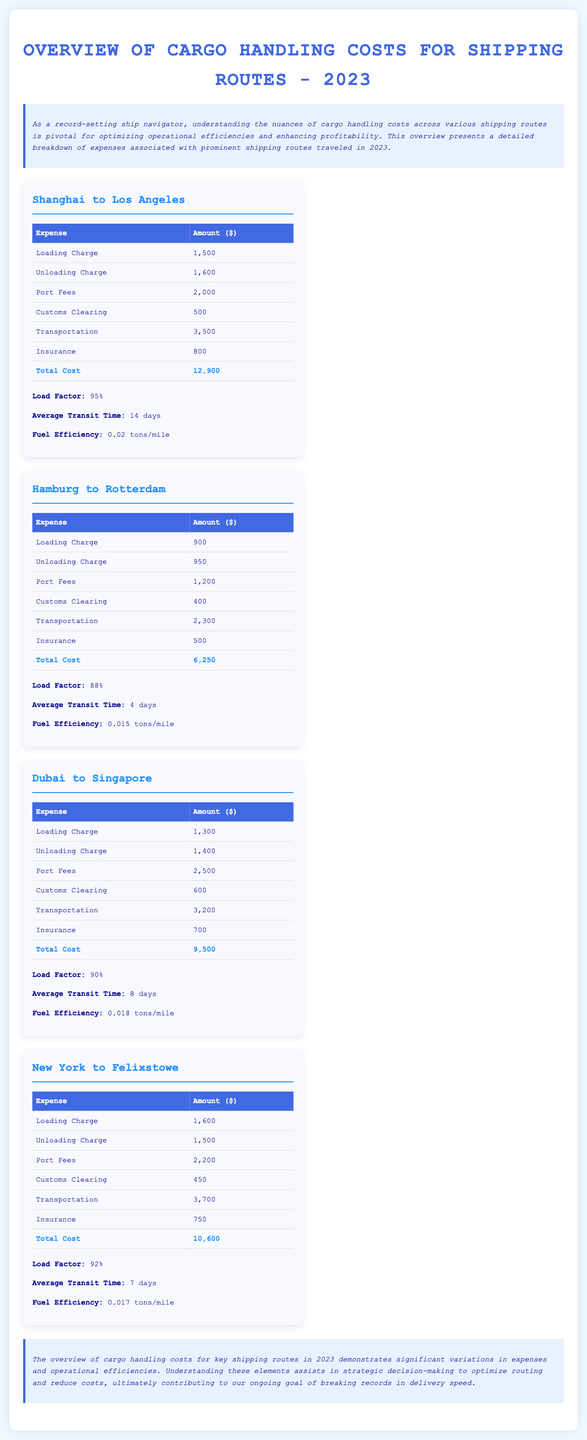what is the total cost for the Shanghai to Los Angeles route? The total cost for the Shanghai to Los Angeles route is specifically mentioned in the expenses table under total cost.
Answer: 12,900 what is the average transit time for the Hamburg to Rotterdam route? The average transit time is provided in the operational efficiencies section for that specific route.
Answer: 4 days which route has the highest loading charge? By comparing the loading charges for each route provided, we can determine which one is the highest.
Answer: New York to Felixstowe what is the load factor for the Dubai to Singapore route? The load factor is indicated in the efficiency details for the Dubai to Singapore route.
Answer: 90% how much is the insurance cost for the Hamburg to Rotterdam route? The insurance cost can be found in the expenses table for the Hamburg to Rotterdam route.
Answer: 500 which route has the lowest total cost? By analyzing the total costs listed for each route, we can identify the lowest value.
Answer: Hamburg to Rotterdam what is the fuel efficiency for the New York to Felixstowe route? The fuel efficiency is mentioned in the operational efficiencies section for that route.
Answer: 0.017 tons/mile what are the port fees for the Dubai to Singapore route? The port fees are described in the expenses table specifically for that route.
Answer: 2,500 what is the loading charge for the Guangzhou to London route? The document does not include a loading charge for that route, as it is not listed.
Answer: Not listed 